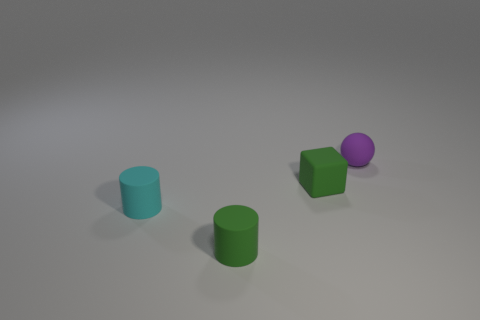What is the size of the rubber thing that is in front of the purple rubber object and behind the cyan object?
Your answer should be compact. Small. How many other objects are the same color as the small block?
Offer a terse response. 1. There is a green cylinder; are there any purple balls behind it?
Your answer should be very brief. Yes. There is a green cube; does it have the same size as the rubber object that is in front of the cyan thing?
Give a very brief answer. Yes. How many other objects are the same material as the tiny cube?
Keep it short and to the point. 3. There is a tiny rubber thing that is to the left of the small purple sphere and behind the small cyan cylinder; what shape is it?
Give a very brief answer. Cube. What is the shape of the small cyan object that is made of the same material as the small green cylinder?
Provide a short and direct response. Cylinder. Is there anything else that has the same shape as the small purple object?
Ensure brevity in your answer.  No. There is a rubber object on the right side of the tiny green rubber thing that is to the right of the tiny rubber cylinder on the right side of the small cyan rubber object; what is its color?
Provide a succinct answer. Purple. Is the number of tiny cyan matte cylinders that are behind the green matte cube less than the number of small things that are on the right side of the tiny green cylinder?
Offer a very short reply. Yes. 